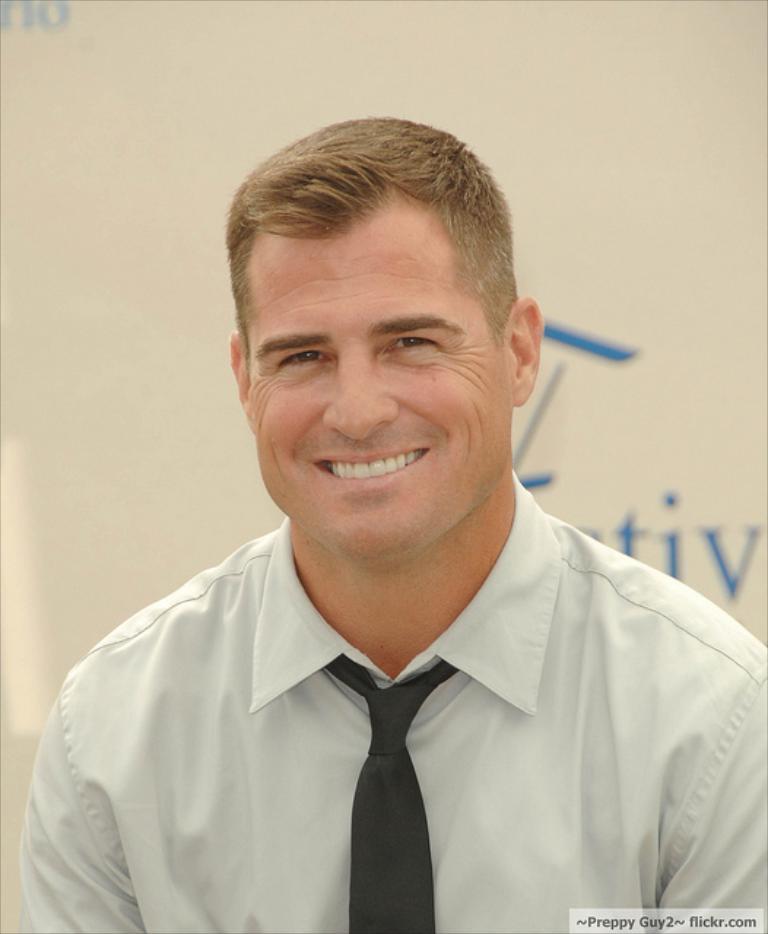Describe this image in one or two sentences. In this image in the foreground there is one man who is wearing white color shirt and tie and smiling, and in the background there is a board. On the board there is text. 